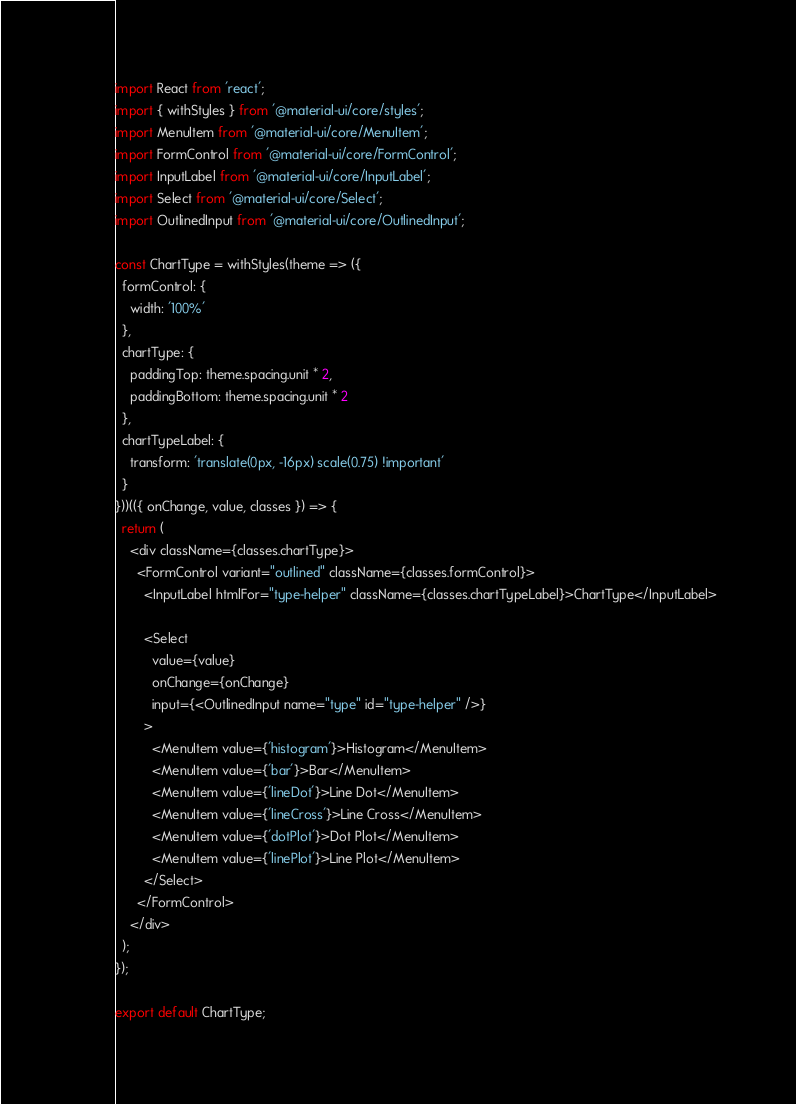Convert code to text. <code><loc_0><loc_0><loc_500><loc_500><_JavaScript_>import React from 'react';
import { withStyles } from '@material-ui/core/styles';
import MenuItem from '@material-ui/core/MenuItem';
import FormControl from '@material-ui/core/FormControl';
import InputLabel from '@material-ui/core/InputLabel';
import Select from '@material-ui/core/Select';
import OutlinedInput from '@material-ui/core/OutlinedInput';

const ChartType = withStyles(theme => ({
  formControl: {
    width: '100%'
  },
  chartType: {
    paddingTop: theme.spacing.unit * 2,
    paddingBottom: theme.spacing.unit * 2
  },
  chartTypeLabel: {
    transform: 'translate(0px, -16px) scale(0.75) !important'
  }
}))(({ onChange, value, classes }) => {
  return (
    <div className={classes.chartType}>
      <FormControl variant="outlined" className={classes.formControl}>
        <InputLabel htmlFor="type-helper" className={classes.chartTypeLabel}>ChartType</InputLabel>

        <Select
          value={value}
          onChange={onChange}
          input={<OutlinedInput name="type" id="type-helper" />}
        >
          <MenuItem value={'histogram'}>Histogram</MenuItem>
          <MenuItem value={'bar'}>Bar</MenuItem>
          <MenuItem value={'lineDot'}>Line Dot</MenuItem>
          <MenuItem value={'lineCross'}>Line Cross</MenuItem>
          <MenuItem value={'dotPlot'}>Dot Plot</MenuItem>
          <MenuItem value={'linePlot'}>Line Plot</MenuItem>
        </Select>
      </FormControl>
    </div>
  );
});

export default ChartType;
</code> 